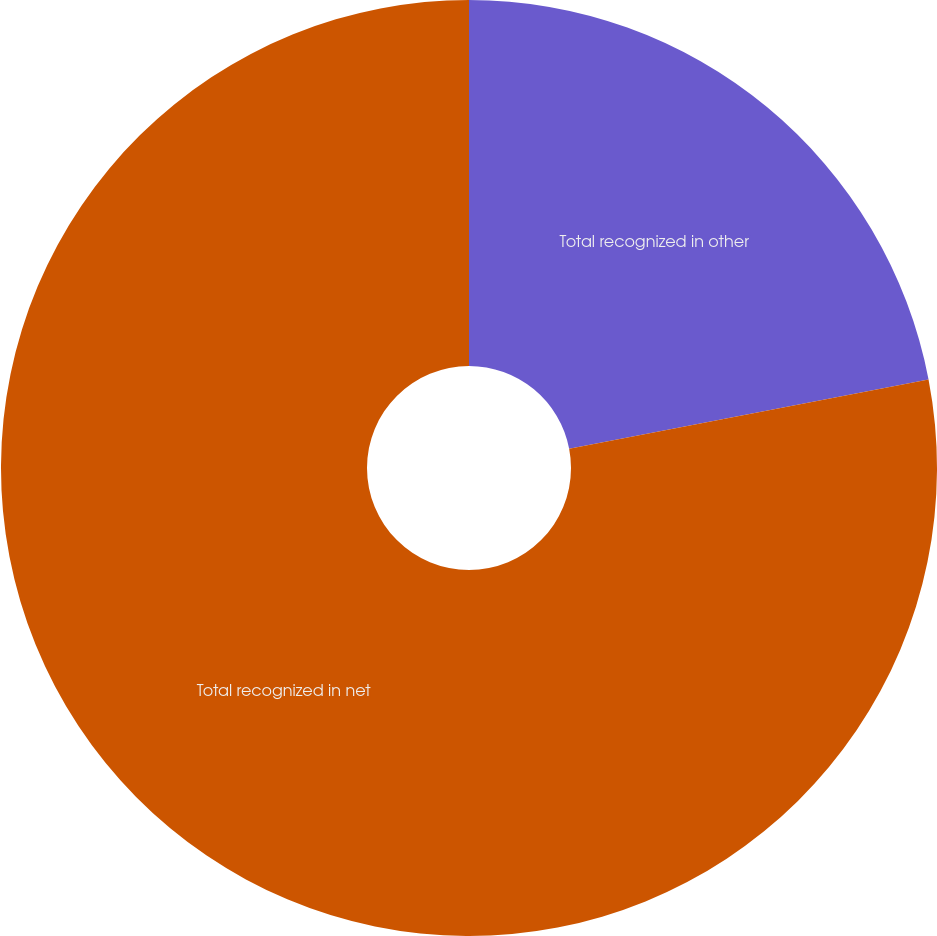Convert chart. <chart><loc_0><loc_0><loc_500><loc_500><pie_chart><fcel>Total recognized in other<fcel>Total recognized in net<nl><fcel>21.97%<fcel>78.03%<nl></chart> 